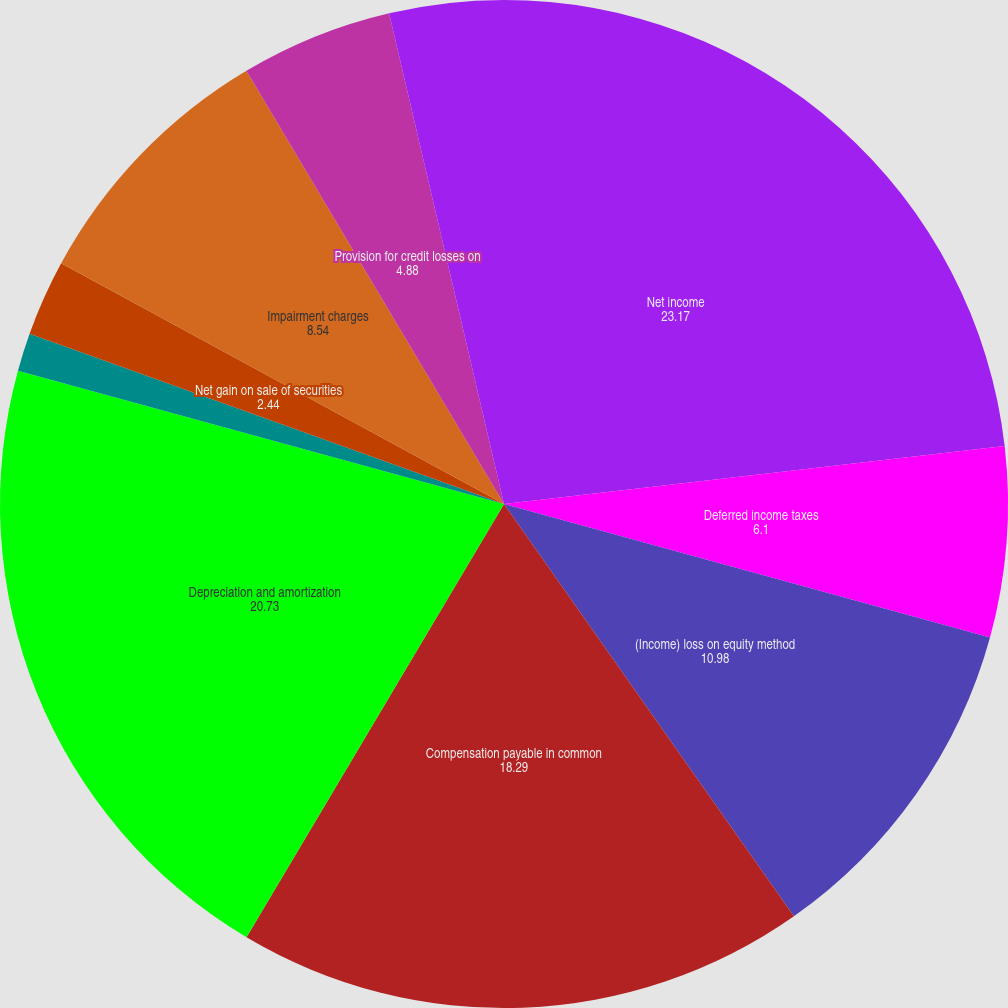Convert chart. <chart><loc_0><loc_0><loc_500><loc_500><pie_chart><fcel>Net income<fcel>Deferred income taxes<fcel>(Income) loss on equity method<fcel>Compensation payable in common<fcel>Depreciation and amortization<fcel>Net gain on business<fcel>Net gain on sale of securities<fcel>Impairment charges<fcel>Provision for credit losses on<fcel>Other non-cash adjustments to<nl><fcel>23.17%<fcel>6.1%<fcel>10.98%<fcel>18.29%<fcel>20.73%<fcel>1.22%<fcel>2.44%<fcel>8.54%<fcel>4.88%<fcel>3.66%<nl></chart> 